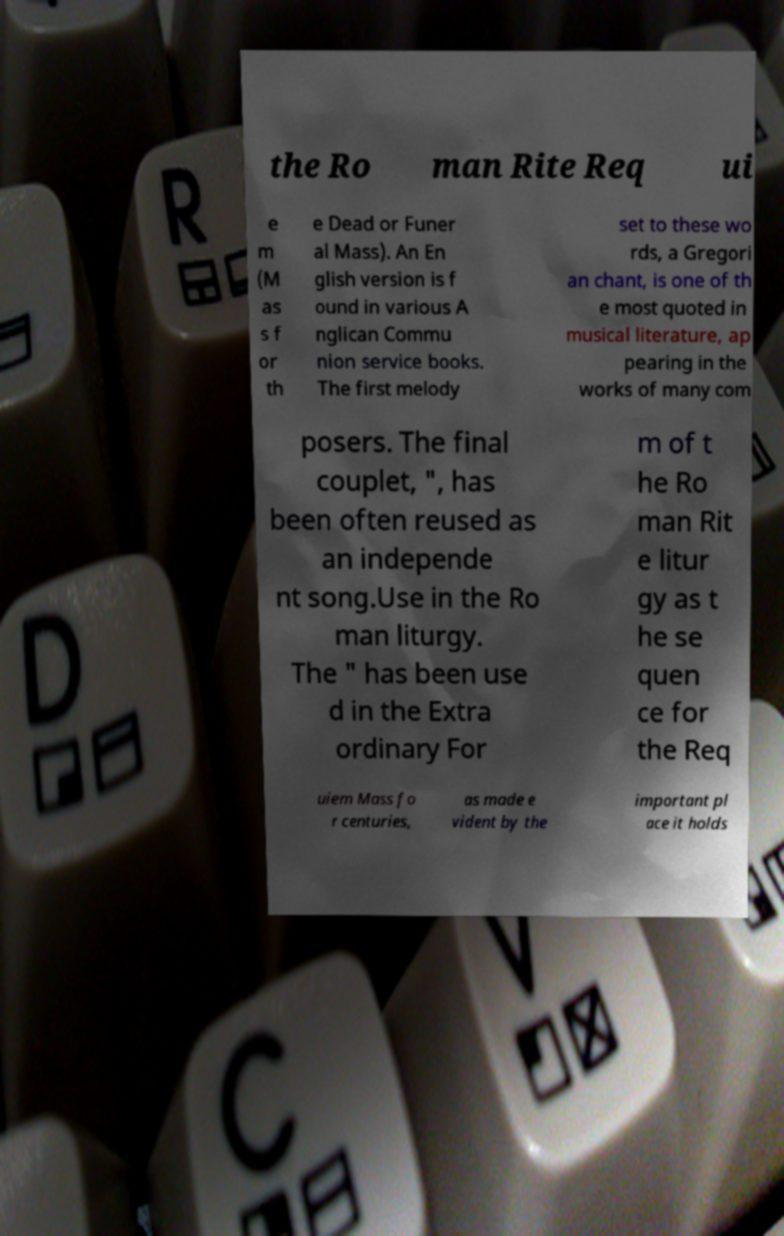Can you accurately transcribe the text from the provided image for me? the Ro man Rite Req ui e m (M as s f or th e Dead or Funer al Mass). An En glish version is f ound in various A nglican Commu nion service books. The first melody set to these wo rds, a Gregori an chant, is one of th e most quoted in musical literature, ap pearing in the works of many com posers. The final couplet, ", has been often reused as an independe nt song.Use in the Ro man liturgy. The " has been use d in the Extra ordinary For m of t he Ro man Rit e litur gy as t he se quen ce for the Req uiem Mass fo r centuries, as made e vident by the important pl ace it holds 